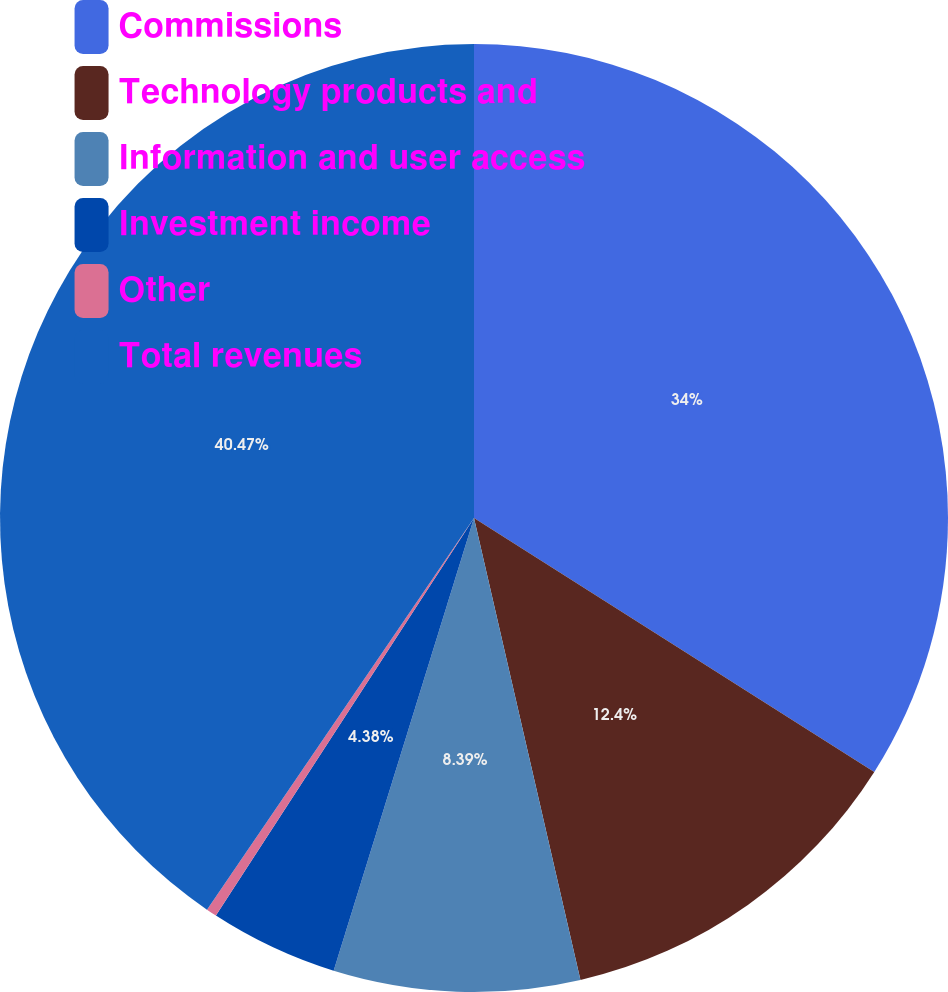Convert chart. <chart><loc_0><loc_0><loc_500><loc_500><pie_chart><fcel>Commissions<fcel>Technology products and<fcel>Information and user access<fcel>Investment income<fcel>Other<fcel>Total revenues<nl><fcel>34.0%<fcel>12.4%<fcel>8.39%<fcel>4.38%<fcel>0.36%<fcel>40.48%<nl></chart> 